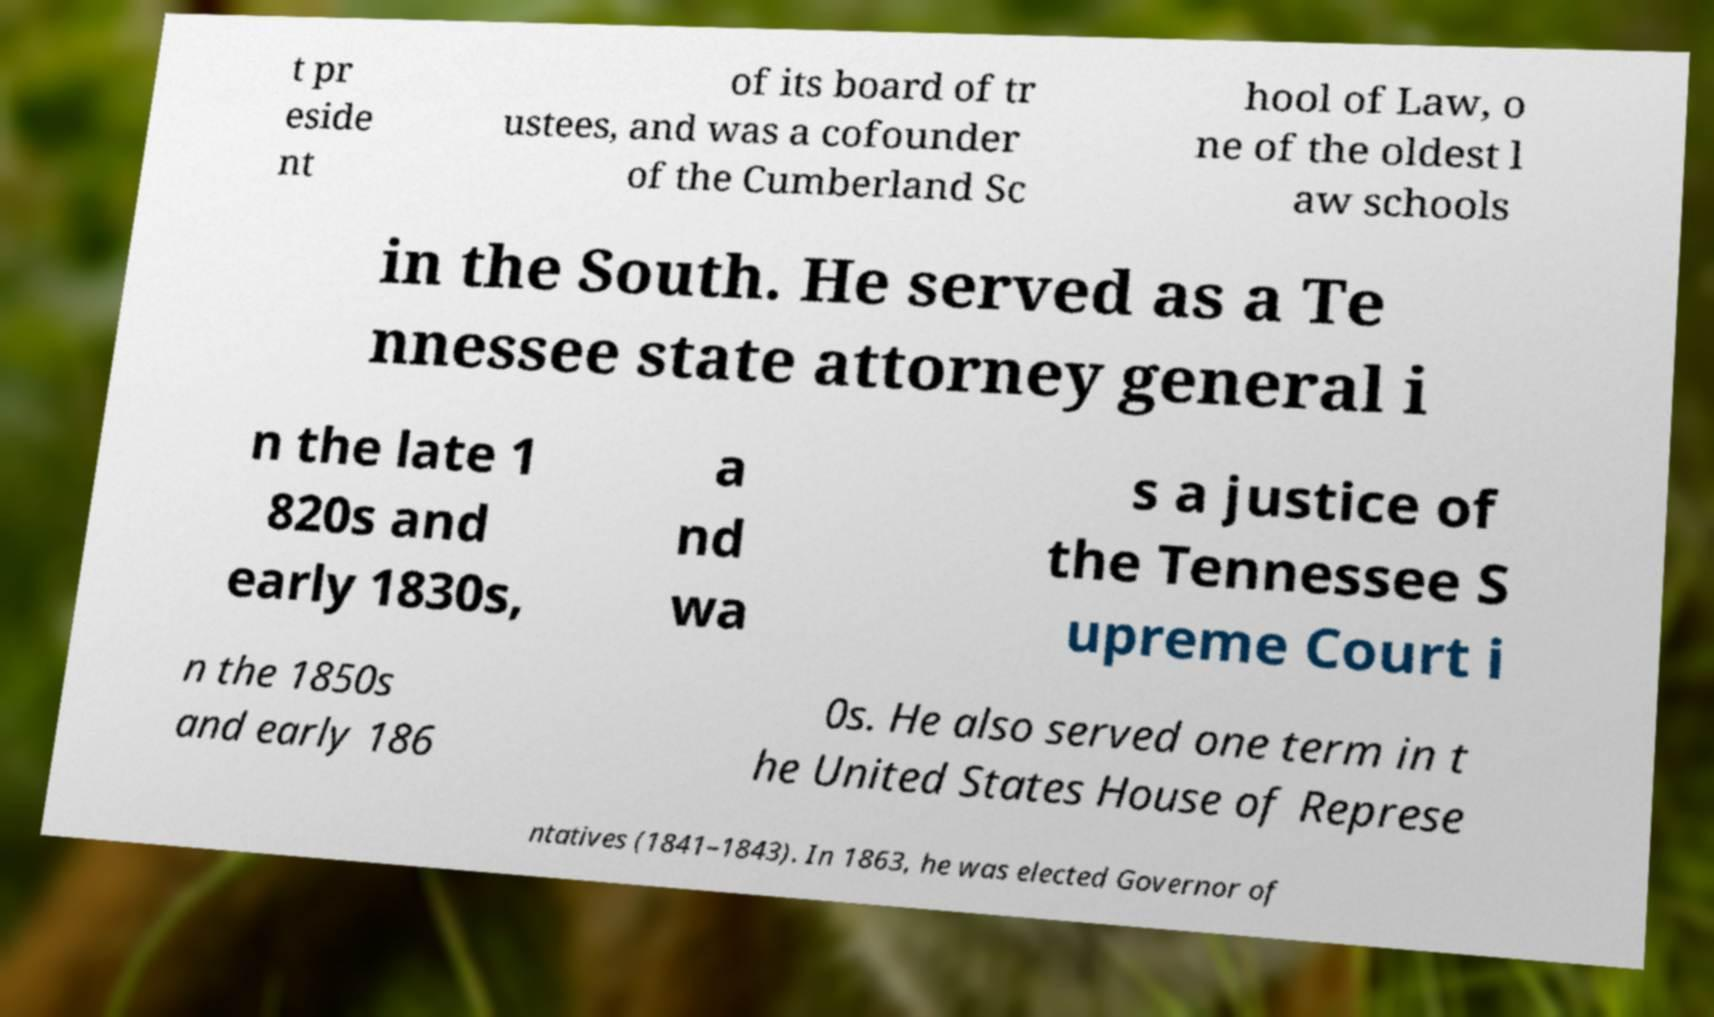I need the written content from this picture converted into text. Can you do that? t pr eside nt of its board of tr ustees, and was a cofounder of the Cumberland Sc hool of Law, o ne of the oldest l aw schools in the South. He served as a Te nnessee state attorney general i n the late 1 820s and early 1830s, a nd wa s a justice of the Tennessee S upreme Court i n the 1850s and early 186 0s. He also served one term in t he United States House of Represe ntatives (1841–1843). In 1863, he was elected Governor of 